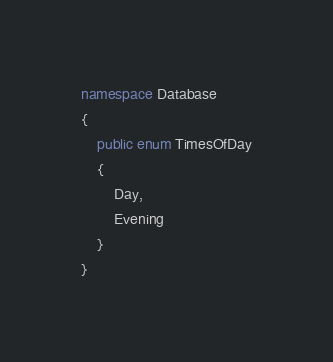Convert code to text. <code><loc_0><loc_0><loc_500><loc_500><_C#_>namespace Database
{
    public enum TimesOfDay
    {
        Day,
        Evening
    }
}</code> 